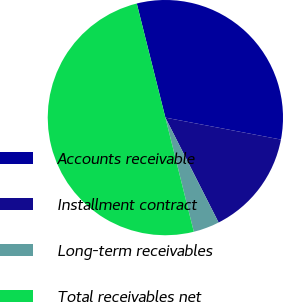Convert chart to OTSL. <chart><loc_0><loc_0><loc_500><loc_500><pie_chart><fcel>Accounts receivable<fcel>Installment contract<fcel>Long-term receivables<fcel>Total receivables net<nl><fcel>31.9%<fcel>14.54%<fcel>3.59%<fcel>49.98%<nl></chart> 